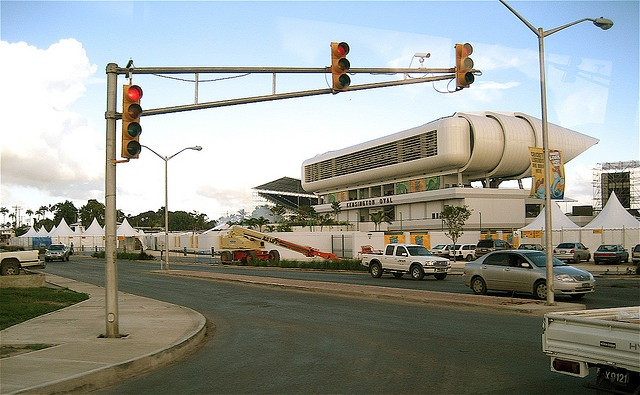Describe the objects in this image and their specific colors. I can see truck in lightblue, gray, black, and darkgray tones, car in lightblue, black, gray, and darkgreen tones, truck in lightblue, black, tan, maroon, and olive tones, truck in lightblue, black, darkgray, tan, and gray tones, and traffic light in lightblue, black, brown, and maroon tones in this image. 